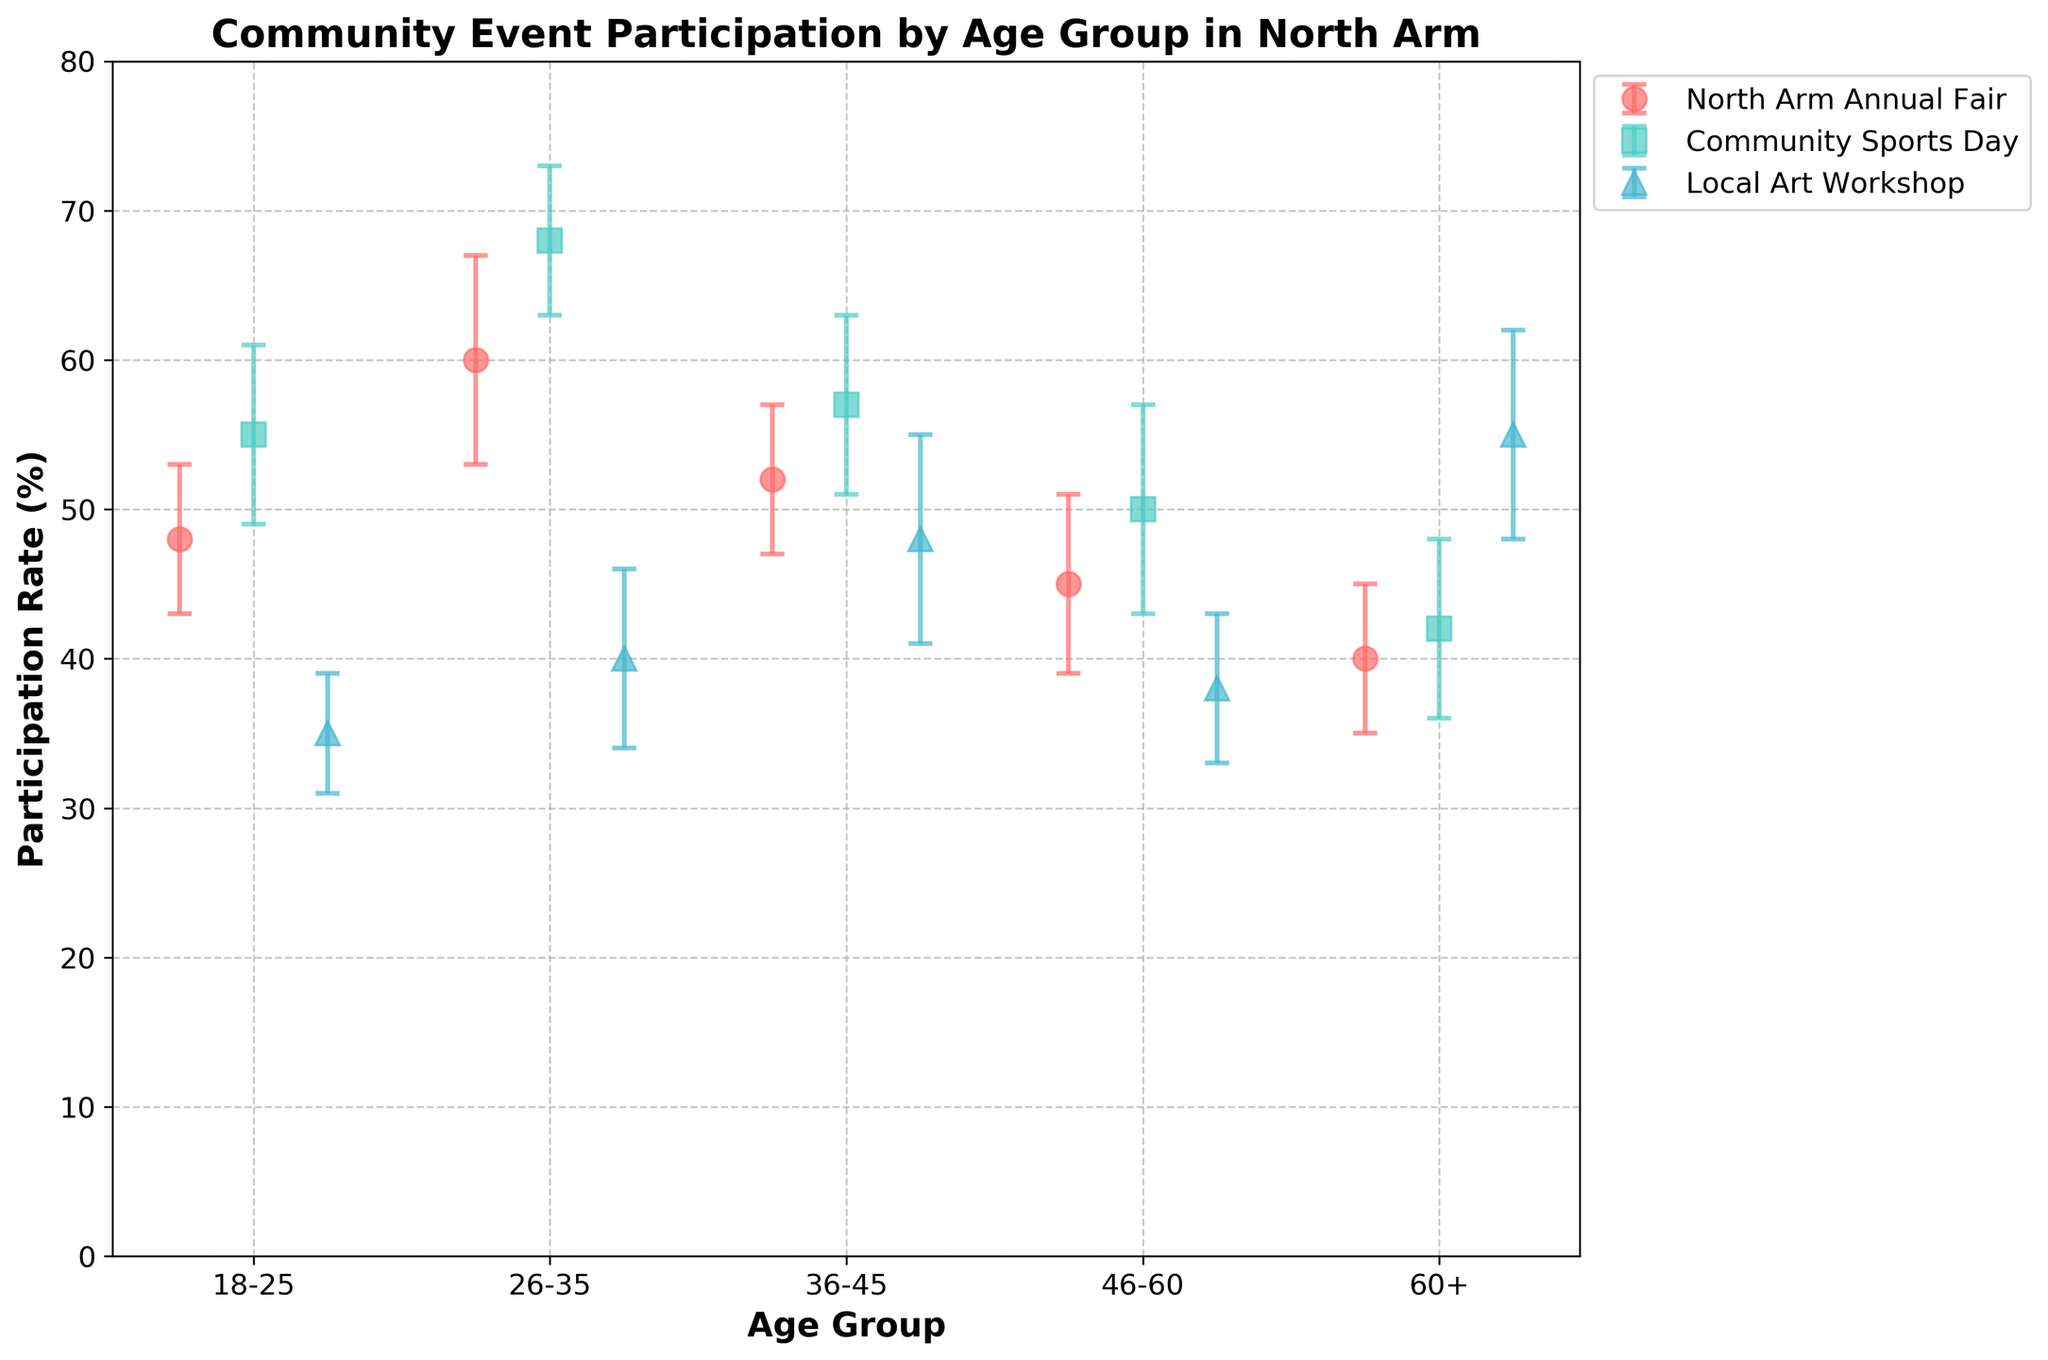What is the participation rate for the Local Art Workshop among those aged 60+? To find the answer, look at the data point corresponding to the 60+ age group under the Local Art Workshop category.
Answer: 55% Which community event has the highest participation rate for the 26-35 age group? Check the participation rates for the 26-35 age group in each of the three community events and identify the highest value. The rates are North Arm Annual Fair (60%), Community Sports Day (68%), and Local Art Workshop (40%).
Answer: Community Sports Day How does the participation rate for the North Arm Annual Fair compare between the 18-25 and 46-60 age groups? Compare the rates for the 18-25 (48%) and 46-60 (45%) age groups for the North Arm Annual Fair.
Answer: 18-25 has higher participation What’s the difference in participation rates for the Community Sports Day between the 36-45 and 60+ age groups? Subtract the participation rate for the 60+ age group (42%) from that of the 36-45 age group (57%).
Answer: 15% Which age group shows the highest participation in the Local Art Workshop? Look at the participation rates of all age groups for the Local Art Workshop and identify the highest rate.
Answer: 60+ For which event is the variability in participation highest for the 26-35 age group? Check the standard deviations for all events for the 26-35 age group. The standard deviations are North Arm Annual Fair (7), Community Sports Day (5), and Local Art Workshop (6).
Answer: North Arm Annual Fair What is the participation rate range for the Community Sports Day across all age groups? To find the range, identify the minimum (42% for 60+) and maximum (68% for 26-35) participation rates for the Community Sports Day and subtract the minimum from the maximum.
Answer: 26% Which age group has the smallest error bars for the North Arm Annual Fair? Compare the error bar (standard deviation) sizes for the North Arm Annual Fair across all age groups. The standard deviations are 18-25 (5), 26-35 (7), 36-45 (5), 46-60 (6), and 60+ (5).
Answer: 18-25, 36-45, 60+ What's the average participation rate for the Local Art Workshop across all age groups? Calculate the average by summing up the participation rates for all age groups (35 + 40 + 48 + 38 + 55) and dividing by the number of age groups (5). The sum is 216, so the average is 216/5.
Answer: 43.2% 